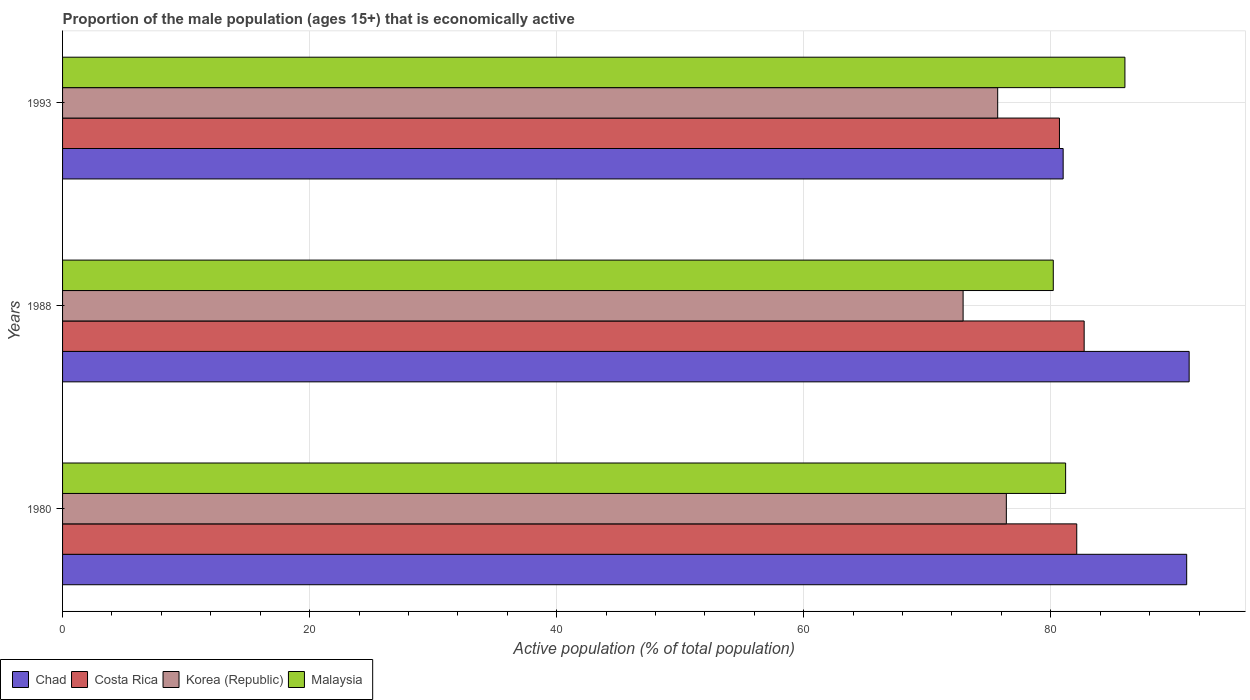How many groups of bars are there?
Offer a very short reply. 3. Are the number of bars per tick equal to the number of legend labels?
Provide a succinct answer. Yes. Are the number of bars on each tick of the Y-axis equal?
Provide a succinct answer. Yes. How many bars are there on the 2nd tick from the bottom?
Your answer should be very brief. 4. What is the label of the 1st group of bars from the top?
Ensure brevity in your answer.  1993. What is the proportion of the male population that is economically active in Chad in 1993?
Your answer should be very brief. 81. Across all years, what is the maximum proportion of the male population that is economically active in Malaysia?
Make the answer very short. 86. Across all years, what is the minimum proportion of the male population that is economically active in Costa Rica?
Make the answer very short. 80.7. In which year was the proportion of the male population that is economically active in Malaysia minimum?
Keep it short and to the point. 1988. What is the total proportion of the male population that is economically active in Malaysia in the graph?
Make the answer very short. 247.4. What is the difference between the proportion of the male population that is economically active in Korea (Republic) in 1980 and the proportion of the male population that is economically active in Chad in 1988?
Provide a short and direct response. -14.8. What is the average proportion of the male population that is economically active in Costa Rica per year?
Offer a terse response. 81.83. What is the ratio of the proportion of the male population that is economically active in Korea (Republic) in 1988 to that in 1993?
Keep it short and to the point. 0.96. Is the difference between the proportion of the male population that is economically active in Costa Rica in 1980 and 1993 greater than the difference between the proportion of the male population that is economically active in Chad in 1980 and 1993?
Give a very brief answer. No. What is the difference between the highest and the second highest proportion of the male population that is economically active in Malaysia?
Offer a terse response. 4.8. What is the difference between the highest and the lowest proportion of the male population that is economically active in Costa Rica?
Provide a succinct answer. 2. Is the sum of the proportion of the male population that is economically active in Costa Rica in 1980 and 1988 greater than the maximum proportion of the male population that is economically active in Chad across all years?
Offer a very short reply. Yes. What does the 4th bar from the top in 1988 represents?
Provide a succinct answer. Chad. What does the 4th bar from the bottom in 1993 represents?
Make the answer very short. Malaysia. Is it the case that in every year, the sum of the proportion of the male population that is economically active in Costa Rica and proportion of the male population that is economically active in Korea (Republic) is greater than the proportion of the male population that is economically active in Malaysia?
Ensure brevity in your answer.  Yes. How many bars are there?
Keep it short and to the point. 12. Are the values on the major ticks of X-axis written in scientific E-notation?
Keep it short and to the point. No. Does the graph contain any zero values?
Your response must be concise. No. Does the graph contain grids?
Offer a very short reply. Yes. Where does the legend appear in the graph?
Ensure brevity in your answer.  Bottom left. How are the legend labels stacked?
Keep it short and to the point. Horizontal. What is the title of the graph?
Your answer should be compact. Proportion of the male population (ages 15+) that is economically active. Does "Bermuda" appear as one of the legend labels in the graph?
Your answer should be compact. No. What is the label or title of the X-axis?
Provide a succinct answer. Active population (% of total population). What is the label or title of the Y-axis?
Provide a short and direct response. Years. What is the Active population (% of total population) of Chad in 1980?
Ensure brevity in your answer.  91. What is the Active population (% of total population) in Costa Rica in 1980?
Your answer should be very brief. 82.1. What is the Active population (% of total population) in Korea (Republic) in 1980?
Make the answer very short. 76.4. What is the Active population (% of total population) in Malaysia in 1980?
Your answer should be very brief. 81.2. What is the Active population (% of total population) of Chad in 1988?
Provide a succinct answer. 91.2. What is the Active population (% of total population) of Costa Rica in 1988?
Your answer should be very brief. 82.7. What is the Active population (% of total population) in Korea (Republic) in 1988?
Ensure brevity in your answer.  72.9. What is the Active population (% of total population) in Malaysia in 1988?
Offer a terse response. 80.2. What is the Active population (% of total population) of Costa Rica in 1993?
Offer a very short reply. 80.7. What is the Active population (% of total population) of Korea (Republic) in 1993?
Make the answer very short. 75.7. What is the Active population (% of total population) of Malaysia in 1993?
Offer a terse response. 86. Across all years, what is the maximum Active population (% of total population) in Chad?
Provide a succinct answer. 91.2. Across all years, what is the maximum Active population (% of total population) of Costa Rica?
Give a very brief answer. 82.7. Across all years, what is the maximum Active population (% of total population) in Korea (Republic)?
Keep it short and to the point. 76.4. Across all years, what is the minimum Active population (% of total population) of Chad?
Offer a very short reply. 81. Across all years, what is the minimum Active population (% of total population) of Costa Rica?
Make the answer very short. 80.7. Across all years, what is the minimum Active population (% of total population) in Korea (Republic)?
Provide a short and direct response. 72.9. Across all years, what is the minimum Active population (% of total population) of Malaysia?
Make the answer very short. 80.2. What is the total Active population (% of total population) in Chad in the graph?
Ensure brevity in your answer.  263.2. What is the total Active population (% of total population) in Costa Rica in the graph?
Offer a terse response. 245.5. What is the total Active population (% of total population) of Korea (Republic) in the graph?
Ensure brevity in your answer.  225. What is the total Active population (% of total population) in Malaysia in the graph?
Offer a terse response. 247.4. What is the difference between the Active population (% of total population) in Costa Rica in 1980 and that in 1988?
Provide a succinct answer. -0.6. What is the difference between the Active population (% of total population) of Korea (Republic) in 1980 and that in 1988?
Your response must be concise. 3.5. What is the difference between the Active population (% of total population) of Chad in 1980 and that in 1993?
Your answer should be very brief. 10. What is the difference between the Active population (% of total population) in Costa Rica in 1980 and that in 1993?
Make the answer very short. 1.4. What is the difference between the Active population (% of total population) of Korea (Republic) in 1980 and that in 1993?
Provide a succinct answer. 0.7. What is the difference between the Active population (% of total population) of Chad in 1988 and that in 1993?
Your answer should be compact. 10.2. What is the difference between the Active population (% of total population) in Chad in 1980 and the Active population (% of total population) in Costa Rica in 1988?
Give a very brief answer. 8.3. What is the difference between the Active population (% of total population) of Chad in 1980 and the Active population (% of total population) of Korea (Republic) in 1988?
Provide a short and direct response. 18.1. What is the difference between the Active population (% of total population) of Chad in 1980 and the Active population (% of total population) of Malaysia in 1988?
Ensure brevity in your answer.  10.8. What is the difference between the Active population (% of total population) in Costa Rica in 1980 and the Active population (% of total population) in Korea (Republic) in 1988?
Make the answer very short. 9.2. What is the difference between the Active population (% of total population) of Korea (Republic) in 1980 and the Active population (% of total population) of Malaysia in 1988?
Provide a succinct answer. -3.8. What is the difference between the Active population (% of total population) in Chad in 1980 and the Active population (% of total population) in Malaysia in 1993?
Your answer should be very brief. 5. What is the difference between the Active population (% of total population) of Korea (Republic) in 1980 and the Active population (% of total population) of Malaysia in 1993?
Make the answer very short. -9.6. What is the difference between the Active population (% of total population) in Chad in 1988 and the Active population (% of total population) in Costa Rica in 1993?
Your answer should be very brief. 10.5. What is the difference between the Active population (% of total population) of Chad in 1988 and the Active population (% of total population) of Korea (Republic) in 1993?
Offer a terse response. 15.5. What is the difference between the Active population (% of total population) of Chad in 1988 and the Active population (% of total population) of Malaysia in 1993?
Keep it short and to the point. 5.2. What is the difference between the Active population (% of total population) in Costa Rica in 1988 and the Active population (% of total population) in Korea (Republic) in 1993?
Keep it short and to the point. 7. What is the difference between the Active population (% of total population) in Costa Rica in 1988 and the Active population (% of total population) in Malaysia in 1993?
Provide a succinct answer. -3.3. What is the difference between the Active population (% of total population) in Korea (Republic) in 1988 and the Active population (% of total population) in Malaysia in 1993?
Offer a very short reply. -13.1. What is the average Active population (% of total population) of Chad per year?
Your response must be concise. 87.73. What is the average Active population (% of total population) of Costa Rica per year?
Provide a succinct answer. 81.83. What is the average Active population (% of total population) in Malaysia per year?
Ensure brevity in your answer.  82.47. In the year 1980, what is the difference between the Active population (% of total population) of Chad and Active population (% of total population) of Korea (Republic)?
Ensure brevity in your answer.  14.6. In the year 1980, what is the difference between the Active population (% of total population) in Costa Rica and Active population (% of total population) in Malaysia?
Your answer should be compact. 0.9. In the year 1980, what is the difference between the Active population (% of total population) in Korea (Republic) and Active population (% of total population) in Malaysia?
Make the answer very short. -4.8. In the year 1988, what is the difference between the Active population (% of total population) of Costa Rica and Active population (% of total population) of Korea (Republic)?
Ensure brevity in your answer.  9.8. In the year 1988, what is the difference between the Active population (% of total population) of Costa Rica and Active population (% of total population) of Malaysia?
Give a very brief answer. 2.5. In the year 1993, what is the difference between the Active population (% of total population) in Chad and Active population (% of total population) in Korea (Republic)?
Provide a succinct answer. 5.3. In the year 1993, what is the difference between the Active population (% of total population) in Costa Rica and Active population (% of total population) in Malaysia?
Offer a very short reply. -5.3. In the year 1993, what is the difference between the Active population (% of total population) in Korea (Republic) and Active population (% of total population) in Malaysia?
Your answer should be very brief. -10.3. What is the ratio of the Active population (% of total population) of Korea (Republic) in 1980 to that in 1988?
Ensure brevity in your answer.  1.05. What is the ratio of the Active population (% of total population) of Malaysia in 1980 to that in 1988?
Ensure brevity in your answer.  1.01. What is the ratio of the Active population (% of total population) of Chad in 1980 to that in 1993?
Keep it short and to the point. 1.12. What is the ratio of the Active population (% of total population) of Costa Rica in 1980 to that in 1993?
Offer a terse response. 1.02. What is the ratio of the Active population (% of total population) in Korea (Republic) in 1980 to that in 1993?
Keep it short and to the point. 1.01. What is the ratio of the Active population (% of total population) in Malaysia in 1980 to that in 1993?
Offer a very short reply. 0.94. What is the ratio of the Active population (% of total population) of Chad in 1988 to that in 1993?
Your response must be concise. 1.13. What is the ratio of the Active population (% of total population) of Costa Rica in 1988 to that in 1993?
Provide a short and direct response. 1.02. What is the ratio of the Active population (% of total population) in Korea (Republic) in 1988 to that in 1993?
Give a very brief answer. 0.96. What is the ratio of the Active population (% of total population) in Malaysia in 1988 to that in 1993?
Keep it short and to the point. 0.93. What is the difference between the highest and the second highest Active population (% of total population) of Costa Rica?
Your answer should be very brief. 0.6. What is the difference between the highest and the second highest Active population (% of total population) in Korea (Republic)?
Give a very brief answer. 0.7. What is the difference between the highest and the lowest Active population (% of total population) in Chad?
Make the answer very short. 10.2. What is the difference between the highest and the lowest Active population (% of total population) in Costa Rica?
Offer a terse response. 2. What is the difference between the highest and the lowest Active population (% of total population) of Korea (Republic)?
Offer a very short reply. 3.5. What is the difference between the highest and the lowest Active population (% of total population) of Malaysia?
Make the answer very short. 5.8. 